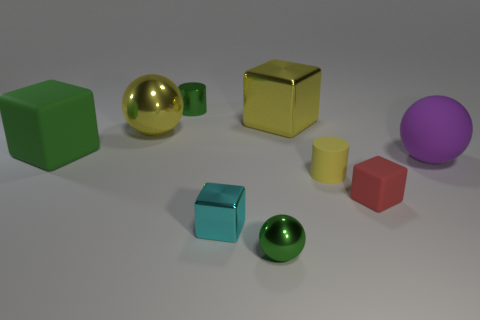What color is the metallic ball that is right of the tiny green shiny cylinder?
Your response must be concise. Green. There is a yellow metal thing that is the same shape as the red matte object; what size is it?
Ensure brevity in your answer.  Large. How many objects are either green metal objects that are in front of the large yellow sphere or objects that are on the right side of the large green block?
Make the answer very short. 8. What size is the thing that is to the right of the cyan block and in front of the small rubber cube?
Your answer should be compact. Small. Do the purple thing and the tiny green thing behind the big green rubber object have the same shape?
Your answer should be compact. No. What number of things are either large balls right of the small red thing or tiny green metal things?
Make the answer very short. 3. Is the small sphere made of the same material as the ball behind the purple matte thing?
Your answer should be very brief. Yes. There is a green object that is on the right side of the metallic object behind the yellow metallic block; what is its shape?
Offer a terse response. Sphere. There is a rubber cylinder; does it have the same color as the small cube in front of the small red matte cube?
Give a very brief answer. No. Is there anything else that is the same material as the small cyan cube?
Your answer should be very brief. Yes. 